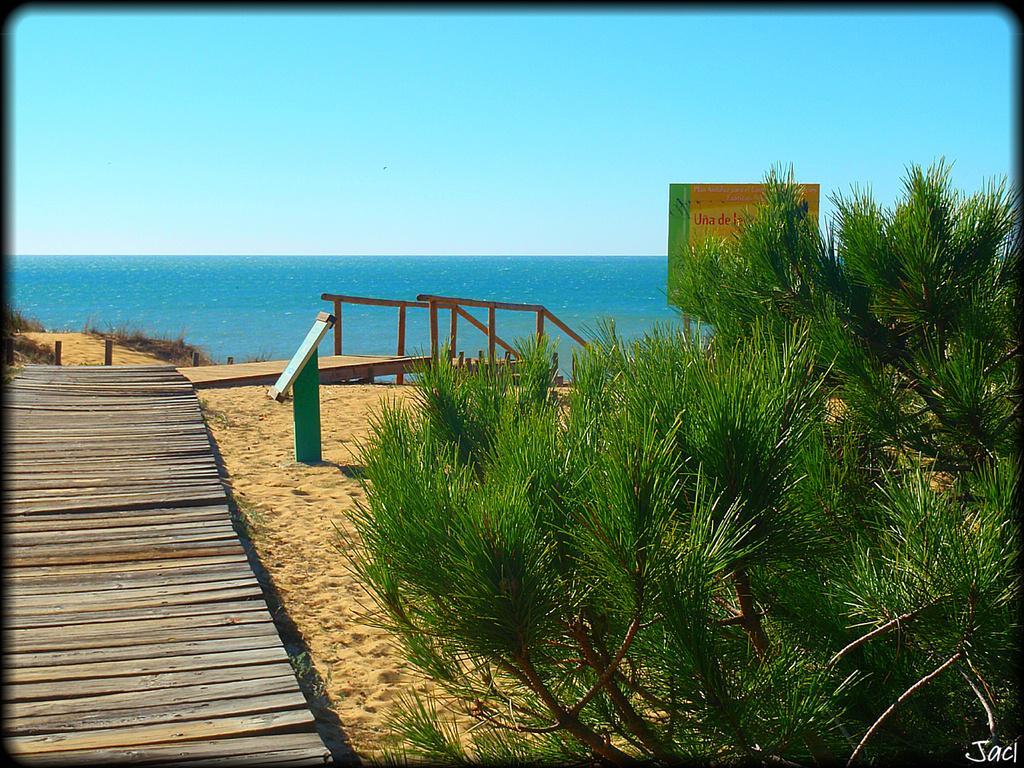How would you summarize this image in a sentence or two? In this image I can see the wooden path. To the side I can see the board and the plants. In the background I can see the railing, water and the sky. 